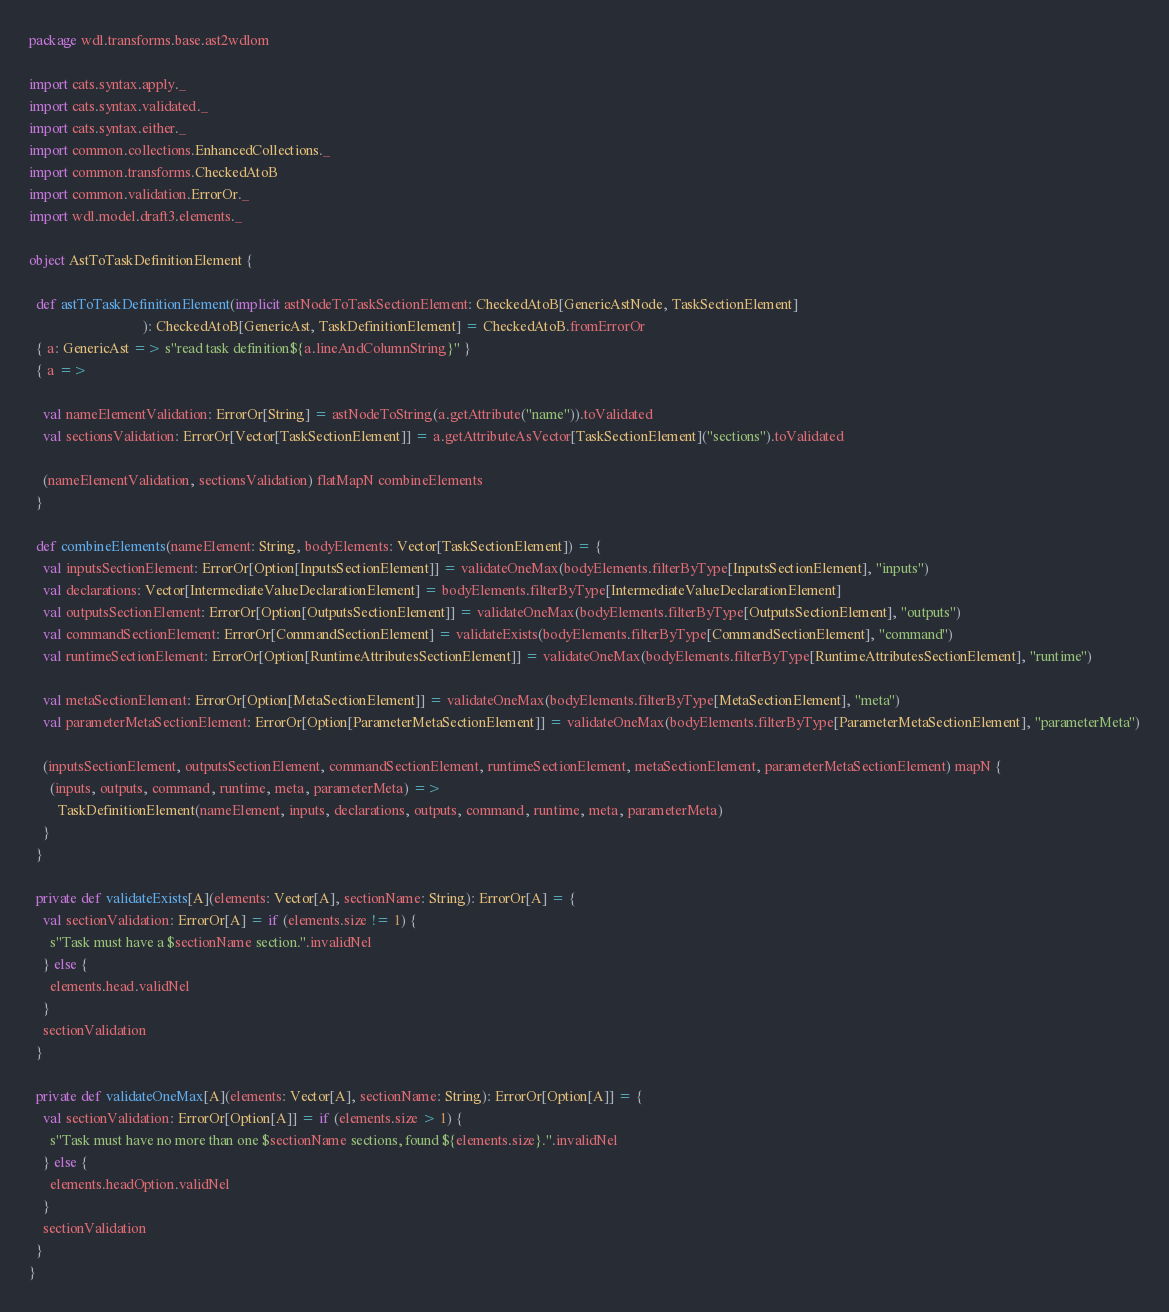<code> <loc_0><loc_0><loc_500><loc_500><_Scala_>package wdl.transforms.base.ast2wdlom

import cats.syntax.apply._
import cats.syntax.validated._
import cats.syntax.either._
import common.collections.EnhancedCollections._
import common.transforms.CheckedAtoB
import common.validation.ErrorOr._
import wdl.model.draft3.elements._

object AstToTaskDefinitionElement {

  def astToTaskDefinitionElement(implicit astNodeToTaskSectionElement: CheckedAtoB[GenericAstNode, TaskSectionElement]
                                ): CheckedAtoB[GenericAst, TaskDefinitionElement] = CheckedAtoB.fromErrorOr
  { a: GenericAst => s"read task definition${a.lineAndColumnString}" }
  { a =>

    val nameElementValidation: ErrorOr[String] = astNodeToString(a.getAttribute("name")).toValidated
    val sectionsValidation: ErrorOr[Vector[TaskSectionElement]] = a.getAttributeAsVector[TaskSectionElement]("sections").toValidated

    (nameElementValidation, sectionsValidation) flatMapN combineElements
  }

  def combineElements(nameElement: String, bodyElements: Vector[TaskSectionElement]) = {
    val inputsSectionElement: ErrorOr[Option[InputsSectionElement]] = validateOneMax(bodyElements.filterByType[InputsSectionElement], "inputs")
    val declarations: Vector[IntermediateValueDeclarationElement] = bodyElements.filterByType[IntermediateValueDeclarationElement]
    val outputsSectionElement: ErrorOr[Option[OutputsSectionElement]] = validateOneMax(bodyElements.filterByType[OutputsSectionElement], "outputs")
    val commandSectionElement: ErrorOr[CommandSectionElement] = validateExists(bodyElements.filterByType[CommandSectionElement], "command")
    val runtimeSectionElement: ErrorOr[Option[RuntimeAttributesSectionElement]] = validateOneMax(bodyElements.filterByType[RuntimeAttributesSectionElement], "runtime")

    val metaSectionElement: ErrorOr[Option[MetaSectionElement]] = validateOneMax(bodyElements.filterByType[MetaSectionElement], "meta")
    val parameterMetaSectionElement: ErrorOr[Option[ParameterMetaSectionElement]] = validateOneMax(bodyElements.filterByType[ParameterMetaSectionElement], "parameterMeta")

    (inputsSectionElement, outputsSectionElement, commandSectionElement, runtimeSectionElement, metaSectionElement, parameterMetaSectionElement) mapN {
      (inputs, outputs, command, runtime, meta, parameterMeta) =>
        TaskDefinitionElement(nameElement, inputs, declarations, outputs, command, runtime, meta, parameterMeta)
    }
  }

  private def validateExists[A](elements: Vector[A], sectionName: String): ErrorOr[A] = {
    val sectionValidation: ErrorOr[A] = if (elements.size != 1) {
      s"Task must have a $sectionName section.".invalidNel
    } else {
      elements.head.validNel
    }
    sectionValidation
  }

  private def validateOneMax[A](elements: Vector[A], sectionName: String): ErrorOr[Option[A]] = {
    val sectionValidation: ErrorOr[Option[A]] = if (elements.size > 1) {
      s"Task must have no more than one $sectionName sections, found ${elements.size}.".invalidNel
    } else {
      elements.headOption.validNel
    }
    sectionValidation
  }
}
</code> 